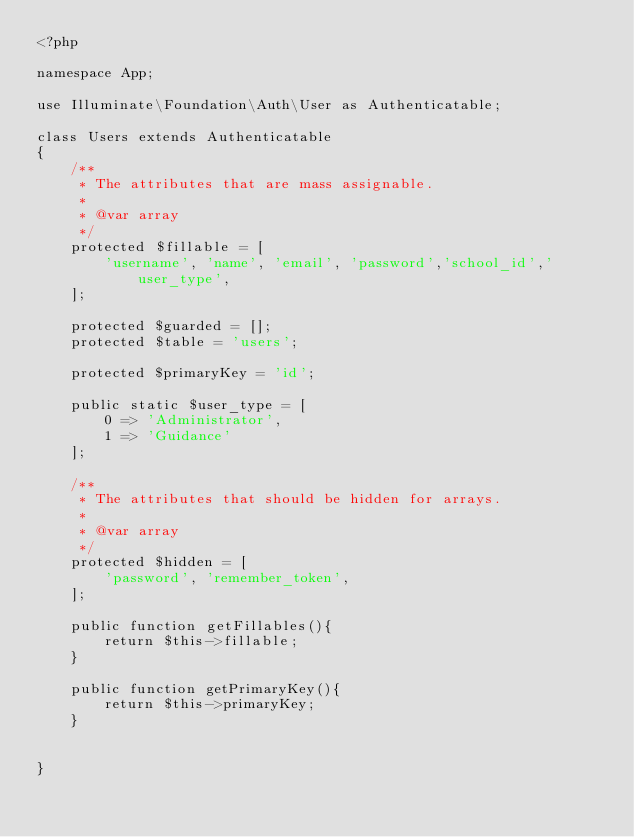Convert code to text. <code><loc_0><loc_0><loc_500><loc_500><_PHP_><?php

namespace App;

use Illuminate\Foundation\Auth\User as Authenticatable;

class Users extends Authenticatable
{
    /**
     * The attributes that are mass assignable.
     *
     * @var array
     */
    protected $fillable = [
        'username', 'name', 'email', 'password','school_id','user_type', 
    ];

    protected $guarded = [];
    protected $table = 'users';

    protected $primaryKey = 'id';

    public static $user_type = [
        0 => 'Administrator',
        1 => 'Guidance'
    ];

    /**
     * The attributes that should be hidden for arrays.
     *
     * @var array
     */
    protected $hidden = [
        'password', 'remember_token',
    ];

    public function getFillables(){
        return $this->fillable;
    }

    public function getPrimaryKey(){
        return $this->primaryKey;
    }
    
    
}
</code> 